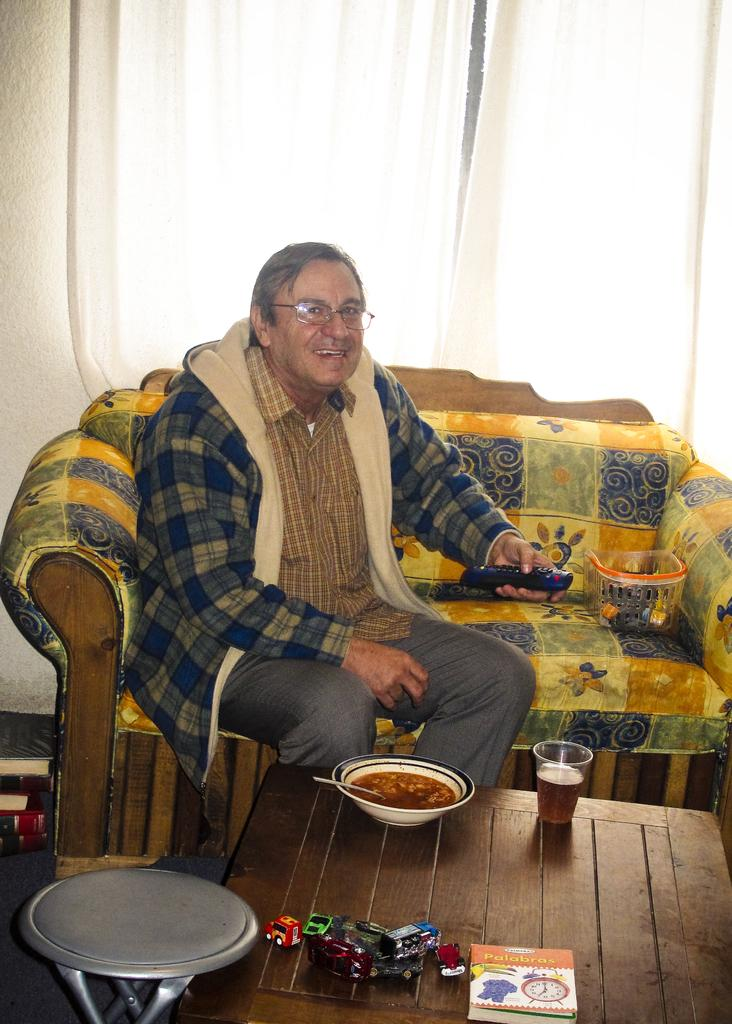What is the man doing in the image? The man is sitting on a sofa in the image. What is in front of the man? There is a table in front of the man. What items can be seen on the table? There is a book, a bowl, and a glass on the table. What type of machine is being used for lunch in the image? There is no machine or lunch present in the image; it only shows a man sitting on a sofa with a table in front of him containing a book, a bowl, and a glass. 